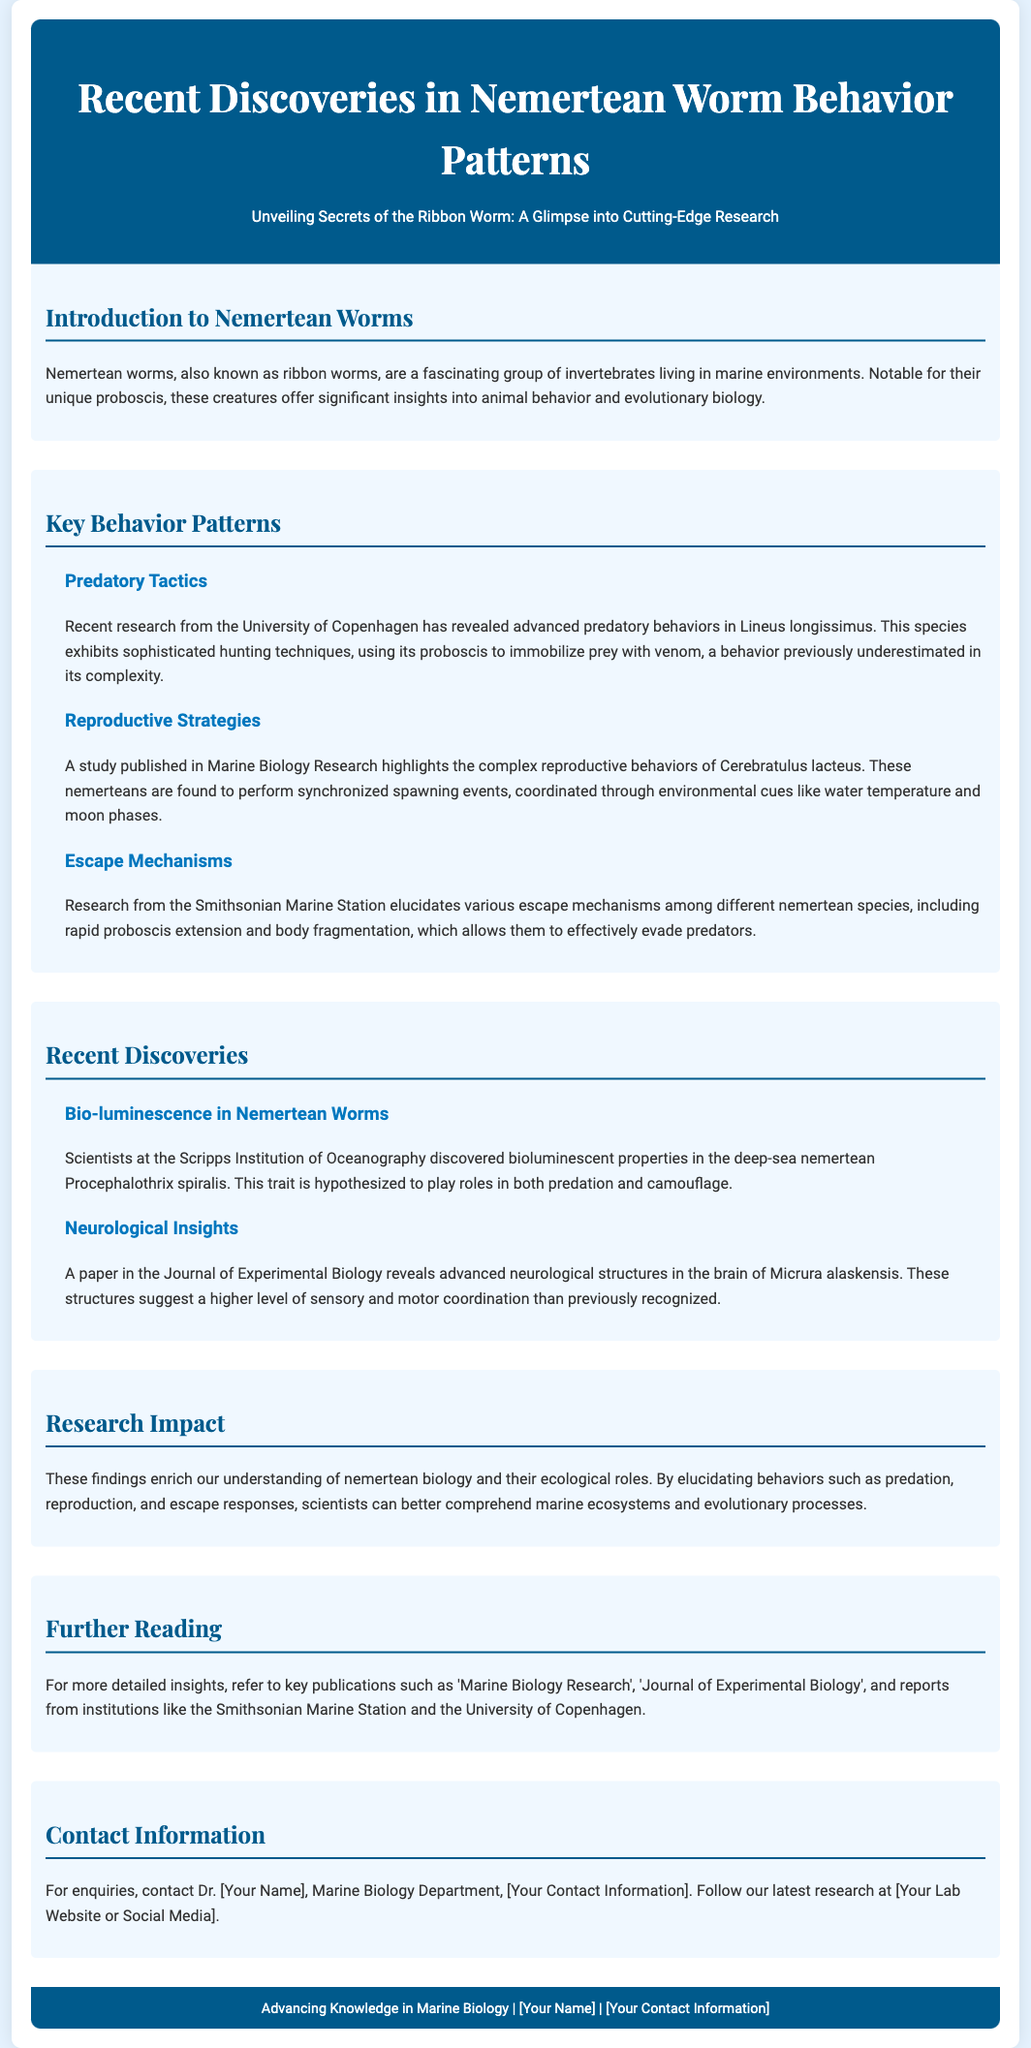what is the primary focus of the document? The document focuses on the latest research findings regarding nemertean worm behavior patterns.
Answer: behavior patterns which species displays advanced predatory tactics? The document mentions Lineus longissimus as exhibiting advanced predatory behaviors.
Answer: Lineus longissimus what environmental cues influence the reproductive strategies of Cerebratulus lacteus? The reproductive strategies are influenced by water temperature and moon phases as per the study mentioned.
Answer: environmental cues which institution discovered bioluminescent properties in a deep-sea nemertean? The Scripps Institution of Oceanography discovered bioluminescent properties.
Answer: Scripps Institution of Oceanography name one escape mechanism identified in nemertean worms. The document discusses rapid proboscis extension as one escape mechanism among nemerteans.
Answer: rapid proboscis extension what type of publication contains insights on the advanced neurological structures of Micrura alaskensis? The advanced neurological structures are detailed in the Journal of Experimental Biology.
Answer: Journal of Experimental Biology how do scientists better understand marine ecosystems according to the document? By elucidating behaviors such as predation, reproduction, and escape responses.
Answer: behaviors who should be contacted for enquiries as per the document? The document indicates Dr. [Your Name] should be contacted for enquiries.
Answer: Dr. [Your Name] 